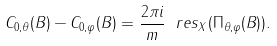Convert formula to latex. <formula><loc_0><loc_0><loc_500><loc_500>C _ { 0 , \theta } ( B ) - C _ { 0 , \varphi } ( B ) = \frac { 2 \pi i } { m } \ r e s _ { X } ( \Pi _ { \theta , \varphi } ( B ) ) .</formula> 